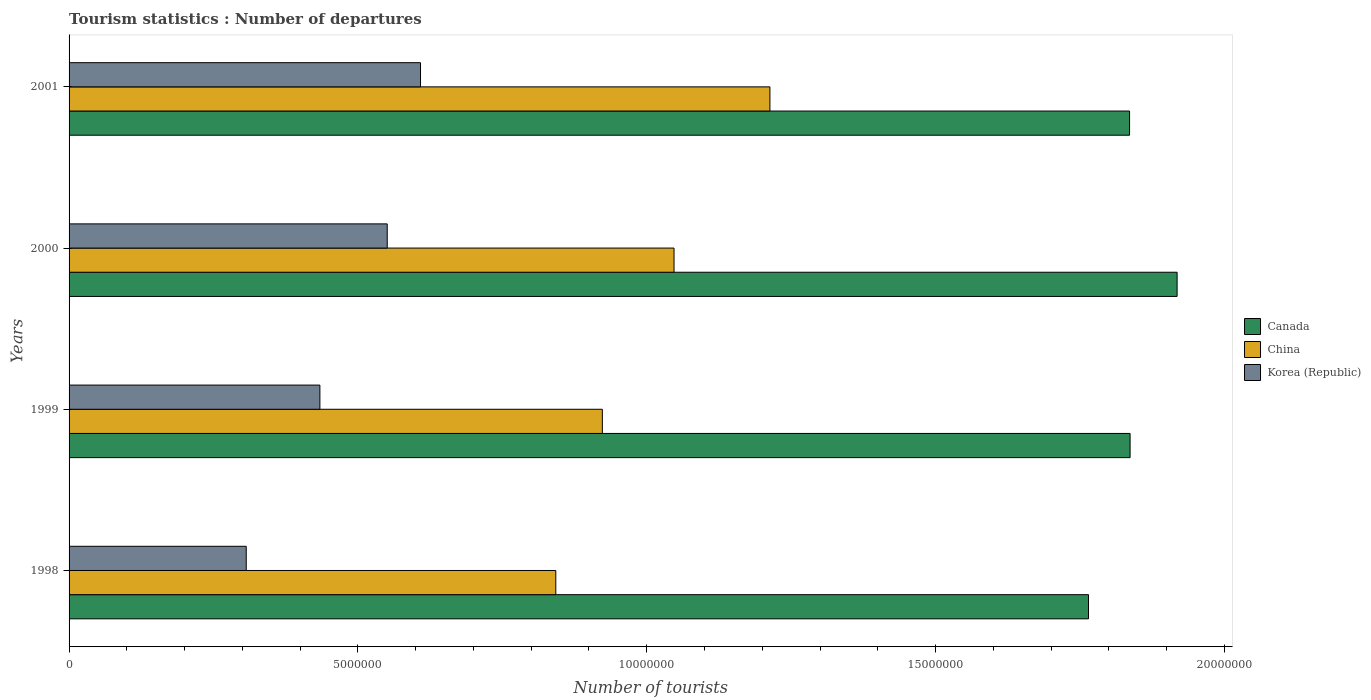How many different coloured bars are there?
Provide a short and direct response. 3. How many bars are there on the 1st tick from the bottom?
Ensure brevity in your answer.  3. What is the number of tourist departures in China in 2001?
Your answer should be compact. 1.21e+07. Across all years, what is the maximum number of tourist departures in Korea (Republic)?
Keep it short and to the point. 6.08e+06. Across all years, what is the minimum number of tourist departures in China?
Offer a very short reply. 8.43e+06. What is the total number of tourist departures in Canada in the graph?
Offer a very short reply. 7.36e+07. What is the difference between the number of tourist departures in Korea (Republic) in 1999 and that in 2001?
Provide a succinct answer. -1.74e+06. What is the difference between the number of tourist departures in China in 2000 and the number of tourist departures in Korea (Republic) in 1998?
Provide a short and direct response. 7.41e+06. What is the average number of tourist departures in China per year?
Offer a very short reply. 1.01e+07. In the year 1998, what is the difference between the number of tourist departures in Canada and number of tourist departures in Korea (Republic)?
Ensure brevity in your answer.  1.46e+07. In how many years, is the number of tourist departures in Canada greater than 13000000 ?
Make the answer very short. 4. What is the ratio of the number of tourist departures in Canada in 1999 to that in 2000?
Your answer should be compact. 0.96. Is the difference between the number of tourist departures in Canada in 1998 and 1999 greater than the difference between the number of tourist departures in Korea (Republic) in 1998 and 1999?
Ensure brevity in your answer.  Yes. What is the difference between the highest and the second highest number of tourist departures in Canada?
Offer a very short reply. 8.14e+05. What is the difference between the highest and the lowest number of tourist departures in Korea (Republic)?
Offer a terse response. 3.02e+06. In how many years, is the number of tourist departures in Korea (Republic) greater than the average number of tourist departures in Korea (Republic) taken over all years?
Offer a very short reply. 2. Is the sum of the number of tourist departures in Canada in 1999 and 2000 greater than the maximum number of tourist departures in China across all years?
Keep it short and to the point. Yes. What does the 1st bar from the bottom in 1998 represents?
Provide a short and direct response. Canada. Is it the case that in every year, the sum of the number of tourist departures in Canada and number of tourist departures in Korea (Republic) is greater than the number of tourist departures in China?
Offer a terse response. Yes. Are all the bars in the graph horizontal?
Keep it short and to the point. Yes. How many years are there in the graph?
Provide a succinct answer. 4. What is the difference between two consecutive major ticks on the X-axis?
Your response must be concise. 5.00e+06. Does the graph contain any zero values?
Offer a terse response. No. How are the legend labels stacked?
Provide a short and direct response. Vertical. What is the title of the graph?
Your answer should be compact. Tourism statistics : Number of departures. What is the label or title of the X-axis?
Make the answer very short. Number of tourists. What is the Number of tourists in Canada in 1998?
Provide a succinct answer. 1.76e+07. What is the Number of tourists in China in 1998?
Offer a very short reply. 8.43e+06. What is the Number of tourists in Korea (Republic) in 1998?
Offer a very short reply. 3.07e+06. What is the Number of tourists of Canada in 1999?
Your response must be concise. 1.84e+07. What is the Number of tourists of China in 1999?
Keep it short and to the point. 9.23e+06. What is the Number of tourists of Korea (Republic) in 1999?
Give a very brief answer. 4.34e+06. What is the Number of tourists in Canada in 2000?
Provide a short and direct response. 1.92e+07. What is the Number of tourists of China in 2000?
Your response must be concise. 1.05e+07. What is the Number of tourists in Korea (Republic) in 2000?
Provide a short and direct response. 5.51e+06. What is the Number of tourists of Canada in 2001?
Your answer should be very brief. 1.84e+07. What is the Number of tourists of China in 2001?
Keep it short and to the point. 1.21e+07. What is the Number of tourists of Korea (Republic) in 2001?
Provide a short and direct response. 6.08e+06. Across all years, what is the maximum Number of tourists of Canada?
Give a very brief answer. 1.92e+07. Across all years, what is the maximum Number of tourists in China?
Offer a terse response. 1.21e+07. Across all years, what is the maximum Number of tourists in Korea (Republic)?
Provide a succinct answer. 6.08e+06. Across all years, what is the minimum Number of tourists of Canada?
Keep it short and to the point. 1.76e+07. Across all years, what is the minimum Number of tourists of China?
Your response must be concise. 8.43e+06. Across all years, what is the minimum Number of tourists of Korea (Republic)?
Provide a short and direct response. 3.07e+06. What is the total Number of tourists of Canada in the graph?
Keep it short and to the point. 7.36e+07. What is the total Number of tourists of China in the graph?
Your response must be concise. 4.03e+07. What is the total Number of tourists of Korea (Republic) in the graph?
Your answer should be very brief. 1.90e+07. What is the difference between the Number of tourists in Canada in 1998 and that in 1999?
Make the answer very short. -7.20e+05. What is the difference between the Number of tourists in China in 1998 and that in 1999?
Make the answer very short. -8.06e+05. What is the difference between the Number of tourists in Korea (Republic) in 1998 and that in 1999?
Ensure brevity in your answer.  -1.28e+06. What is the difference between the Number of tourists of Canada in 1998 and that in 2000?
Provide a short and direct response. -1.53e+06. What is the difference between the Number of tourists of China in 1998 and that in 2000?
Offer a terse response. -2.05e+06. What is the difference between the Number of tourists of Korea (Republic) in 1998 and that in 2000?
Give a very brief answer. -2.44e+06. What is the difference between the Number of tourists in Canada in 1998 and that in 2001?
Your answer should be very brief. -7.11e+05. What is the difference between the Number of tourists in China in 1998 and that in 2001?
Make the answer very short. -3.71e+06. What is the difference between the Number of tourists of Korea (Republic) in 1998 and that in 2001?
Provide a succinct answer. -3.02e+06. What is the difference between the Number of tourists of Canada in 1999 and that in 2000?
Provide a succinct answer. -8.14e+05. What is the difference between the Number of tourists in China in 1999 and that in 2000?
Keep it short and to the point. -1.24e+06. What is the difference between the Number of tourists of Korea (Republic) in 1999 and that in 2000?
Offer a very short reply. -1.17e+06. What is the difference between the Number of tourists of Canada in 1999 and that in 2001?
Your answer should be very brief. 9000. What is the difference between the Number of tourists of China in 1999 and that in 2001?
Provide a succinct answer. -2.90e+06. What is the difference between the Number of tourists of Korea (Republic) in 1999 and that in 2001?
Your response must be concise. -1.74e+06. What is the difference between the Number of tourists of Canada in 2000 and that in 2001?
Your answer should be very brief. 8.23e+05. What is the difference between the Number of tourists of China in 2000 and that in 2001?
Provide a short and direct response. -1.66e+06. What is the difference between the Number of tourists in Korea (Republic) in 2000 and that in 2001?
Make the answer very short. -5.76e+05. What is the difference between the Number of tourists of Canada in 1998 and the Number of tourists of China in 1999?
Keep it short and to the point. 8.42e+06. What is the difference between the Number of tourists of Canada in 1998 and the Number of tourists of Korea (Republic) in 1999?
Your response must be concise. 1.33e+07. What is the difference between the Number of tourists of China in 1998 and the Number of tourists of Korea (Republic) in 1999?
Your answer should be compact. 4.08e+06. What is the difference between the Number of tourists of Canada in 1998 and the Number of tourists of China in 2000?
Provide a succinct answer. 7.18e+06. What is the difference between the Number of tourists of Canada in 1998 and the Number of tourists of Korea (Republic) in 2000?
Make the answer very short. 1.21e+07. What is the difference between the Number of tourists in China in 1998 and the Number of tourists in Korea (Republic) in 2000?
Your answer should be very brief. 2.92e+06. What is the difference between the Number of tourists in Canada in 1998 and the Number of tourists in China in 2001?
Provide a succinct answer. 5.52e+06. What is the difference between the Number of tourists of Canada in 1998 and the Number of tourists of Korea (Republic) in 2001?
Provide a succinct answer. 1.16e+07. What is the difference between the Number of tourists in China in 1998 and the Number of tourists in Korea (Republic) in 2001?
Your response must be concise. 2.34e+06. What is the difference between the Number of tourists of Canada in 1999 and the Number of tourists of China in 2000?
Offer a terse response. 7.90e+06. What is the difference between the Number of tourists in Canada in 1999 and the Number of tourists in Korea (Republic) in 2000?
Offer a very short reply. 1.29e+07. What is the difference between the Number of tourists of China in 1999 and the Number of tourists of Korea (Republic) in 2000?
Provide a succinct answer. 3.72e+06. What is the difference between the Number of tourists of Canada in 1999 and the Number of tourists of China in 2001?
Keep it short and to the point. 6.24e+06. What is the difference between the Number of tourists of Canada in 1999 and the Number of tourists of Korea (Republic) in 2001?
Provide a short and direct response. 1.23e+07. What is the difference between the Number of tourists of China in 1999 and the Number of tourists of Korea (Republic) in 2001?
Your response must be concise. 3.15e+06. What is the difference between the Number of tourists of Canada in 2000 and the Number of tourists of China in 2001?
Provide a succinct answer. 7.05e+06. What is the difference between the Number of tourists in Canada in 2000 and the Number of tourists in Korea (Republic) in 2001?
Offer a terse response. 1.31e+07. What is the difference between the Number of tourists in China in 2000 and the Number of tourists in Korea (Republic) in 2001?
Provide a short and direct response. 4.39e+06. What is the average Number of tourists of Canada per year?
Provide a succinct answer. 1.84e+07. What is the average Number of tourists of China per year?
Offer a terse response. 1.01e+07. What is the average Number of tourists in Korea (Republic) per year?
Your answer should be very brief. 4.75e+06. In the year 1998, what is the difference between the Number of tourists of Canada and Number of tourists of China?
Provide a succinct answer. 9.22e+06. In the year 1998, what is the difference between the Number of tourists in Canada and Number of tourists in Korea (Republic)?
Give a very brief answer. 1.46e+07. In the year 1998, what is the difference between the Number of tourists in China and Number of tourists in Korea (Republic)?
Your response must be concise. 5.36e+06. In the year 1999, what is the difference between the Number of tourists in Canada and Number of tourists in China?
Ensure brevity in your answer.  9.14e+06. In the year 1999, what is the difference between the Number of tourists of Canada and Number of tourists of Korea (Republic)?
Make the answer very short. 1.40e+07. In the year 1999, what is the difference between the Number of tourists of China and Number of tourists of Korea (Republic)?
Give a very brief answer. 4.89e+06. In the year 2000, what is the difference between the Number of tourists in Canada and Number of tourists in China?
Offer a very short reply. 8.71e+06. In the year 2000, what is the difference between the Number of tourists of Canada and Number of tourists of Korea (Republic)?
Offer a terse response. 1.37e+07. In the year 2000, what is the difference between the Number of tourists in China and Number of tourists in Korea (Republic)?
Provide a short and direct response. 4.96e+06. In the year 2001, what is the difference between the Number of tourists of Canada and Number of tourists of China?
Provide a succinct answer. 6.23e+06. In the year 2001, what is the difference between the Number of tourists of Canada and Number of tourists of Korea (Republic)?
Provide a short and direct response. 1.23e+07. In the year 2001, what is the difference between the Number of tourists in China and Number of tourists in Korea (Republic)?
Offer a terse response. 6.05e+06. What is the ratio of the Number of tourists of Canada in 1998 to that in 1999?
Keep it short and to the point. 0.96. What is the ratio of the Number of tourists in China in 1998 to that in 1999?
Offer a very short reply. 0.91. What is the ratio of the Number of tourists in Korea (Republic) in 1998 to that in 1999?
Provide a short and direct response. 0.71. What is the ratio of the Number of tourists of China in 1998 to that in 2000?
Provide a succinct answer. 0.8. What is the ratio of the Number of tourists in Korea (Republic) in 1998 to that in 2000?
Provide a succinct answer. 0.56. What is the ratio of the Number of tourists of Canada in 1998 to that in 2001?
Offer a terse response. 0.96. What is the ratio of the Number of tourists of China in 1998 to that in 2001?
Ensure brevity in your answer.  0.69. What is the ratio of the Number of tourists of Korea (Republic) in 1998 to that in 2001?
Give a very brief answer. 0.5. What is the ratio of the Number of tourists of Canada in 1999 to that in 2000?
Your answer should be compact. 0.96. What is the ratio of the Number of tourists in China in 1999 to that in 2000?
Offer a terse response. 0.88. What is the ratio of the Number of tourists in Korea (Republic) in 1999 to that in 2000?
Provide a short and direct response. 0.79. What is the ratio of the Number of tourists in Canada in 1999 to that in 2001?
Ensure brevity in your answer.  1. What is the ratio of the Number of tourists of China in 1999 to that in 2001?
Your answer should be compact. 0.76. What is the ratio of the Number of tourists of Korea (Republic) in 1999 to that in 2001?
Give a very brief answer. 0.71. What is the ratio of the Number of tourists of Canada in 2000 to that in 2001?
Make the answer very short. 1.04. What is the ratio of the Number of tourists of China in 2000 to that in 2001?
Provide a short and direct response. 0.86. What is the ratio of the Number of tourists in Korea (Republic) in 2000 to that in 2001?
Ensure brevity in your answer.  0.91. What is the difference between the highest and the second highest Number of tourists in Canada?
Give a very brief answer. 8.14e+05. What is the difference between the highest and the second highest Number of tourists in China?
Keep it short and to the point. 1.66e+06. What is the difference between the highest and the second highest Number of tourists of Korea (Republic)?
Your answer should be compact. 5.76e+05. What is the difference between the highest and the lowest Number of tourists in Canada?
Keep it short and to the point. 1.53e+06. What is the difference between the highest and the lowest Number of tourists of China?
Provide a short and direct response. 3.71e+06. What is the difference between the highest and the lowest Number of tourists of Korea (Republic)?
Offer a very short reply. 3.02e+06. 